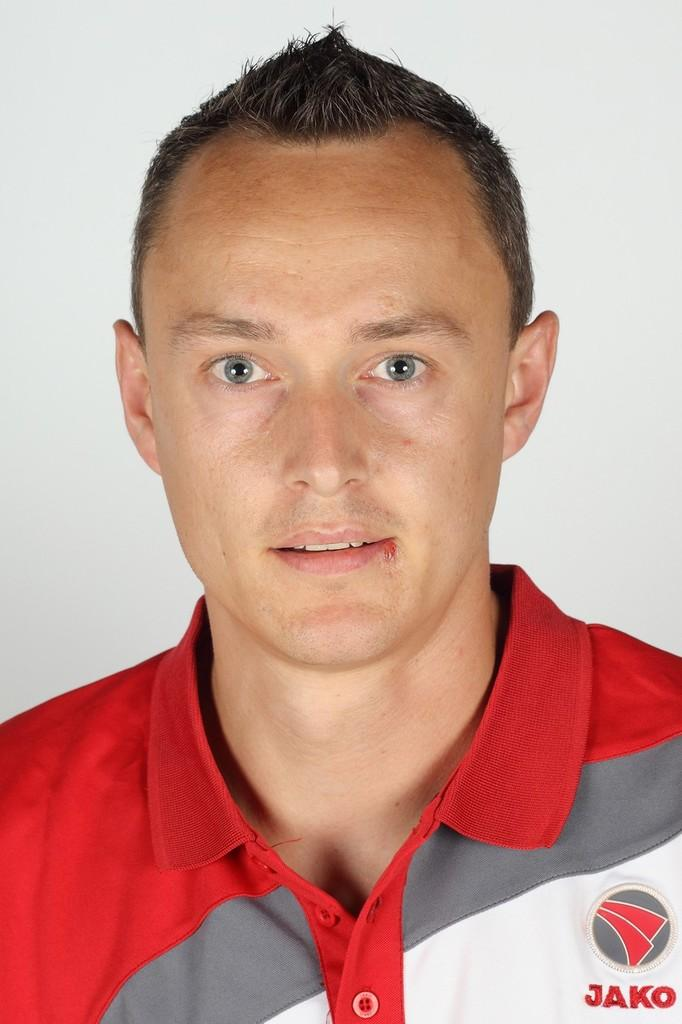<image>
Write a terse but informative summary of the picture. A man with his hair gelled up wearing a red and white shirt that says Jako on it. 